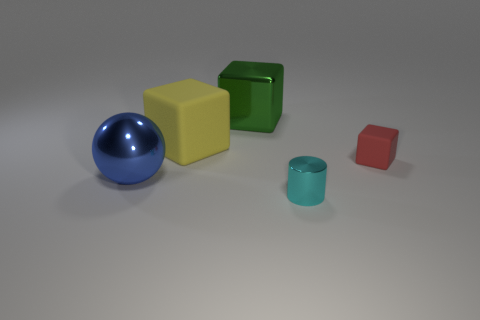How many things are either small brown metal cubes or objects behind the small cyan shiny cylinder?
Your answer should be very brief. 4. Do the large thing behind the large matte cube and the rubber thing behind the small red cube have the same shape?
Give a very brief answer. Yes. Are there any other things that have the same color as the small cube?
Provide a short and direct response. No. There is a big object that is made of the same material as the tiny red thing; what shape is it?
Your answer should be very brief. Cube. What is the material of the thing that is both in front of the red object and behind the metal cylinder?
Provide a succinct answer. Metal. Are there any other things that are the same size as the blue sphere?
Keep it short and to the point. Yes. Does the small shiny cylinder have the same color as the small block?
Keep it short and to the point. No. What number of small metal objects are the same shape as the tiny red rubber thing?
Your answer should be very brief. 0. There is a cube that is the same material as the large blue ball; what size is it?
Your answer should be compact. Large. Is the size of the green thing the same as the yellow thing?
Ensure brevity in your answer.  Yes. 